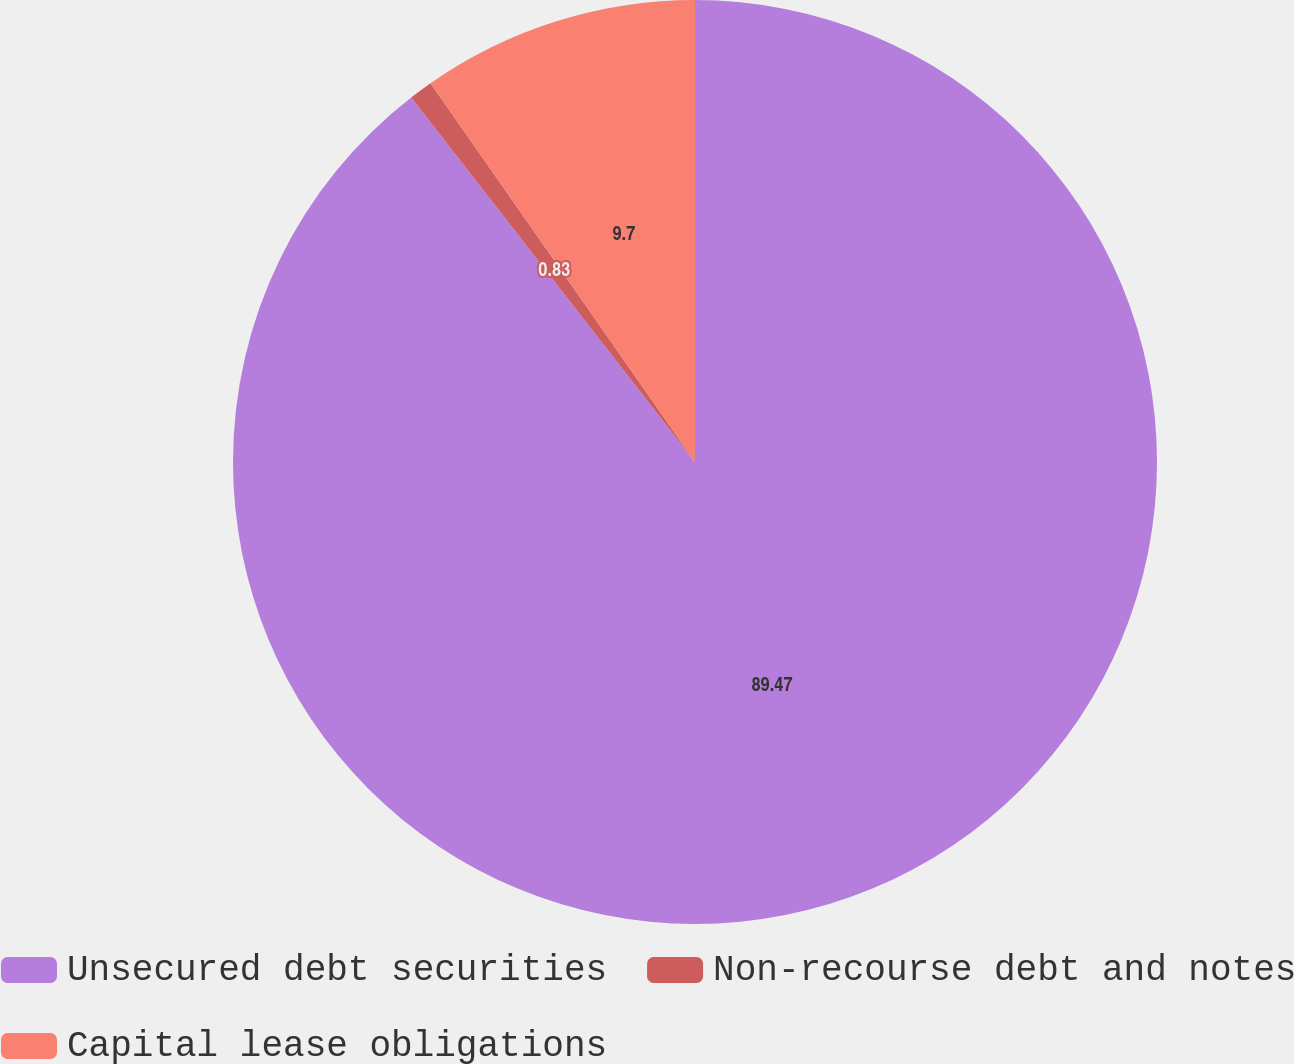Convert chart to OTSL. <chart><loc_0><loc_0><loc_500><loc_500><pie_chart><fcel>Unsecured debt securities<fcel>Non-recourse debt and notes<fcel>Capital lease obligations<nl><fcel>89.47%<fcel>0.83%<fcel>9.7%<nl></chart> 